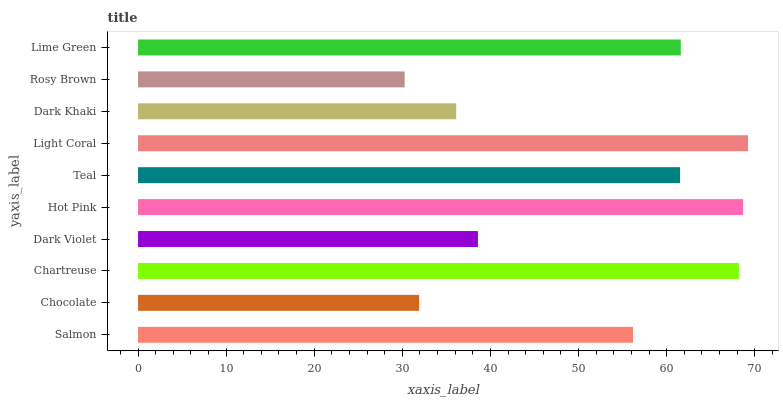Is Rosy Brown the minimum?
Answer yes or no. Yes. Is Light Coral the maximum?
Answer yes or no. Yes. Is Chocolate the minimum?
Answer yes or no. No. Is Chocolate the maximum?
Answer yes or no. No. Is Salmon greater than Chocolate?
Answer yes or no. Yes. Is Chocolate less than Salmon?
Answer yes or no. Yes. Is Chocolate greater than Salmon?
Answer yes or no. No. Is Salmon less than Chocolate?
Answer yes or no. No. Is Teal the high median?
Answer yes or no. Yes. Is Salmon the low median?
Answer yes or no. Yes. Is Rosy Brown the high median?
Answer yes or no. No. Is Teal the low median?
Answer yes or no. No. 